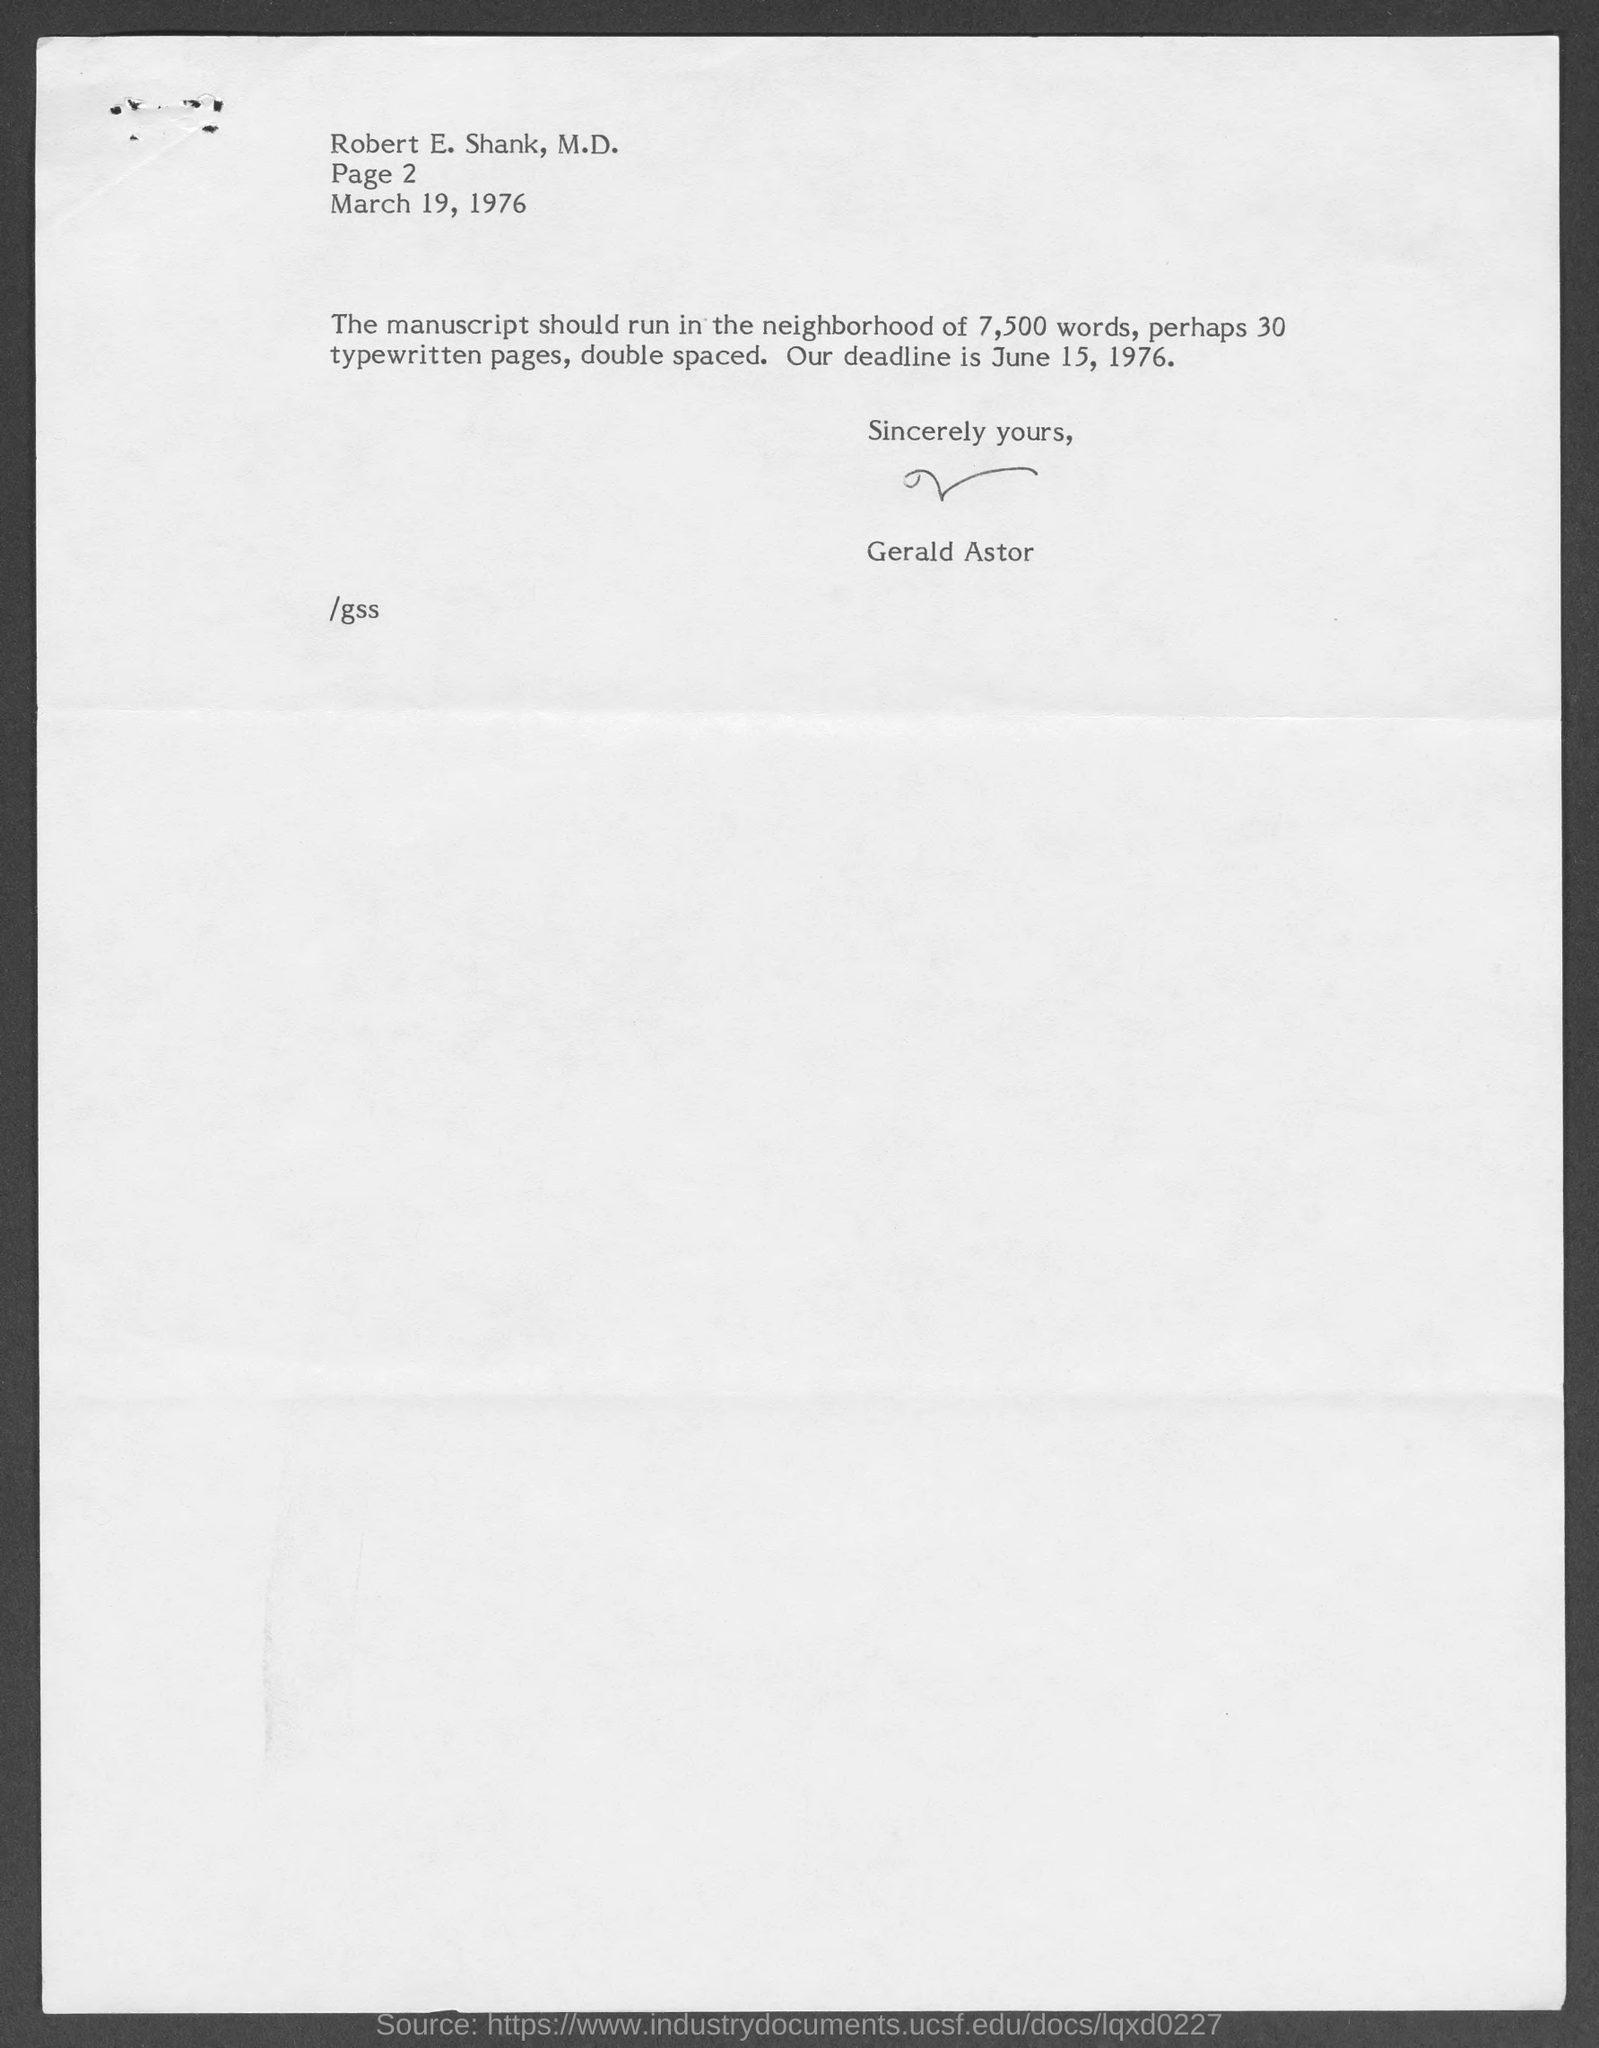What is the date mentioned in the given letter ?
Offer a terse response. March 19, 1976. How many typewritten pages should the manuscript contain ?
Ensure brevity in your answer.  30. What is the date of deadline mentioned in the given letter?
Offer a very short reply. June 15, 1976. Who's sign was there at the end of the letter ?
Offer a very short reply. Gerald Astor. 